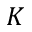<formula> <loc_0><loc_0><loc_500><loc_500>K</formula> 